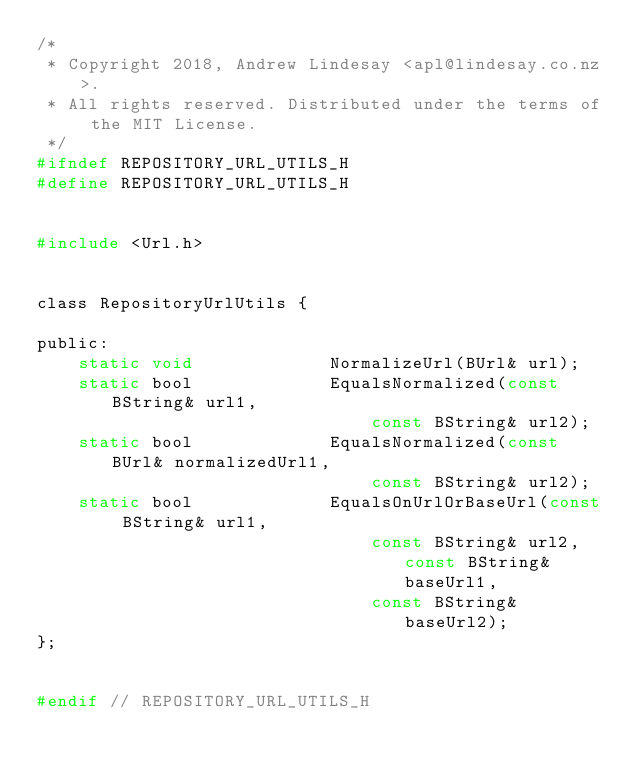Convert code to text. <code><loc_0><loc_0><loc_500><loc_500><_C_>/*
 * Copyright 2018, Andrew Lindesay <apl@lindesay.co.nz>.
 * All rights reserved. Distributed under the terms of the MIT License.
 */
#ifndef REPOSITORY_URL_UTILS_H
#define REPOSITORY_URL_UTILS_H


#include <Url.h>


class RepositoryUrlUtils {

public:
	static void				NormalizeUrl(BUrl& url);
	static bool				EqualsNormalized(const BString& url1,
								const BString& url2);
	static bool				EqualsNormalized(const BUrl& normalizedUrl1,
								const BString& url2);
	static bool				EqualsOnUrlOrBaseUrl(const BString& url1,
								const BString& url2, const BString& baseUrl1,
								const BString& baseUrl2);
};


#endif // REPOSITORY_URL_UTILS_H
</code> 